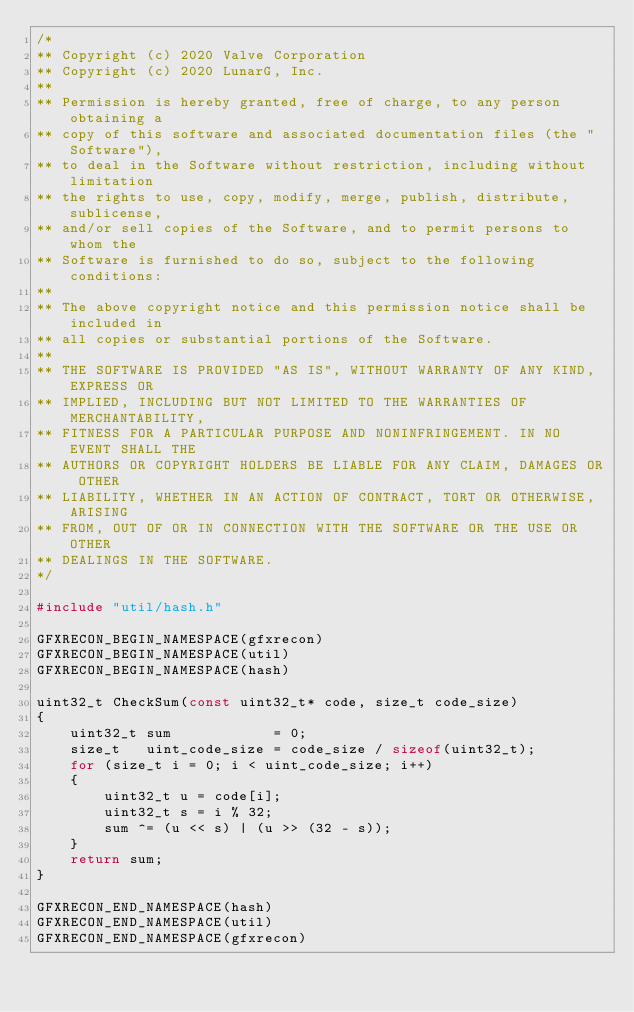Convert code to text. <code><loc_0><loc_0><loc_500><loc_500><_C++_>/*
** Copyright (c) 2020 Valve Corporation
** Copyright (c) 2020 LunarG, Inc.
**
** Permission is hereby granted, free of charge, to any person obtaining a
** copy of this software and associated documentation files (the "Software"),
** to deal in the Software without restriction, including without limitation
** the rights to use, copy, modify, merge, publish, distribute, sublicense,
** and/or sell copies of the Software, and to permit persons to whom the
** Software is furnished to do so, subject to the following conditions:
**
** The above copyright notice and this permission notice shall be included in
** all copies or substantial portions of the Software.
**
** THE SOFTWARE IS PROVIDED "AS IS", WITHOUT WARRANTY OF ANY KIND, EXPRESS OR
** IMPLIED, INCLUDING BUT NOT LIMITED TO THE WARRANTIES OF MERCHANTABILITY,
** FITNESS FOR A PARTICULAR PURPOSE AND NONINFRINGEMENT. IN NO EVENT SHALL THE
** AUTHORS OR COPYRIGHT HOLDERS BE LIABLE FOR ANY CLAIM, DAMAGES OR OTHER
** LIABILITY, WHETHER IN AN ACTION OF CONTRACT, TORT OR OTHERWISE, ARISING
** FROM, OUT OF OR IN CONNECTION WITH THE SOFTWARE OR THE USE OR OTHER
** DEALINGS IN THE SOFTWARE.
*/

#include "util/hash.h"

GFXRECON_BEGIN_NAMESPACE(gfxrecon)
GFXRECON_BEGIN_NAMESPACE(util)
GFXRECON_BEGIN_NAMESPACE(hash)

uint32_t CheckSum(const uint32_t* code, size_t code_size)
{
    uint32_t sum            = 0;
    size_t   uint_code_size = code_size / sizeof(uint32_t);
    for (size_t i = 0; i < uint_code_size; i++)
    {
        uint32_t u = code[i];
        uint32_t s = i % 32;
        sum ^= (u << s) | (u >> (32 - s));
    }
    return sum;
}

GFXRECON_END_NAMESPACE(hash)
GFXRECON_END_NAMESPACE(util)
GFXRECON_END_NAMESPACE(gfxrecon)
</code> 